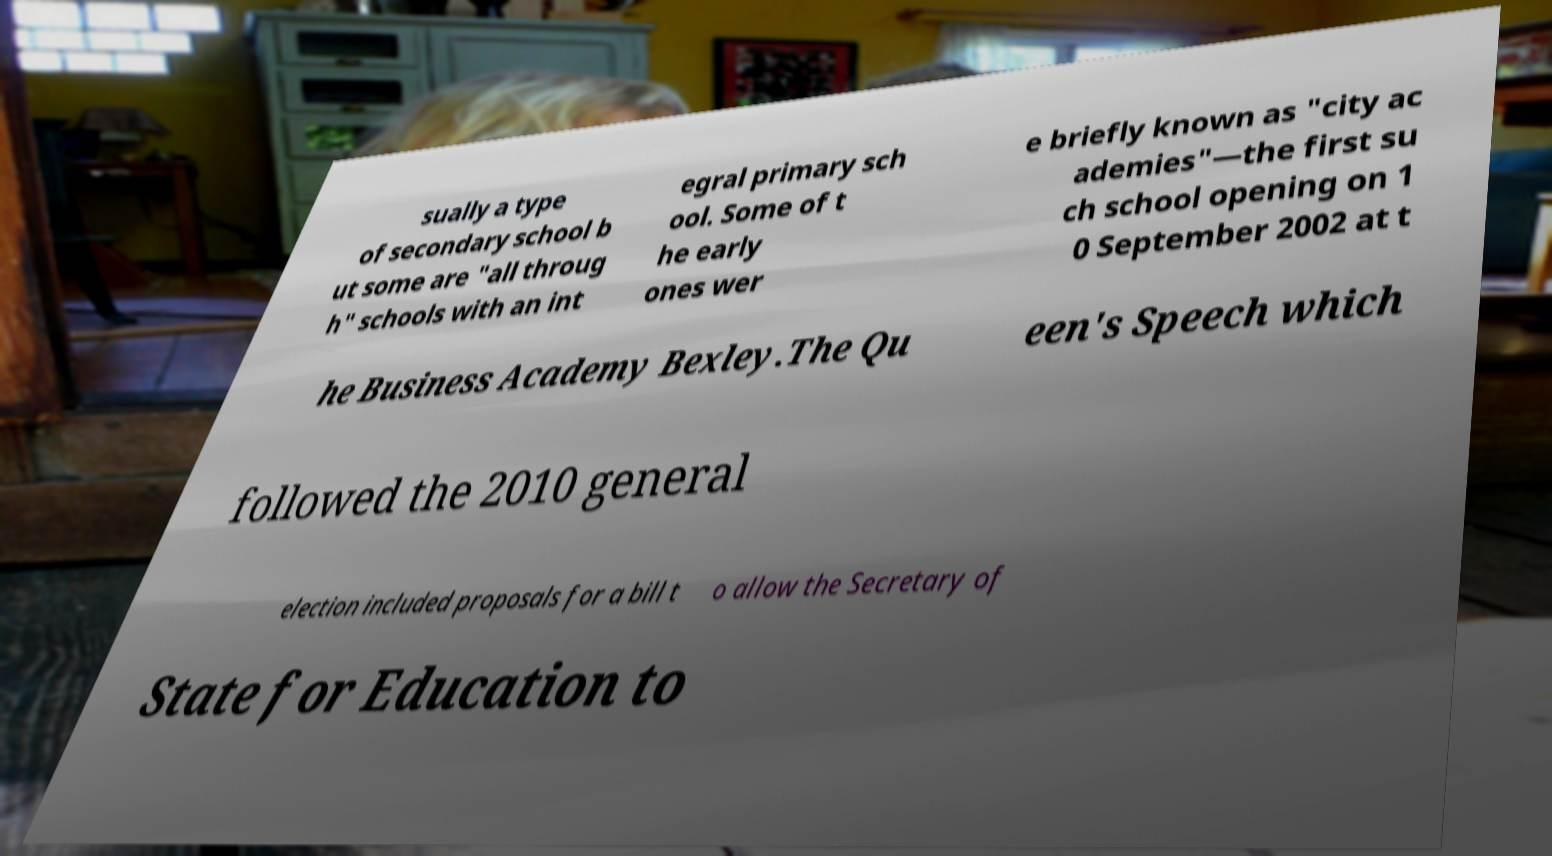There's text embedded in this image that I need extracted. Can you transcribe it verbatim? sually a type of secondary school b ut some are "all throug h" schools with an int egral primary sch ool. Some of t he early ones wer e briefly known as "city ac ademies"—the first su ch school opening on 1 0 September 2002 at t he Business Academy Bexley.The Qu een's Speech which followed the 2010 general election included proposals for a bill t o allow the Secretary of State for Education to 